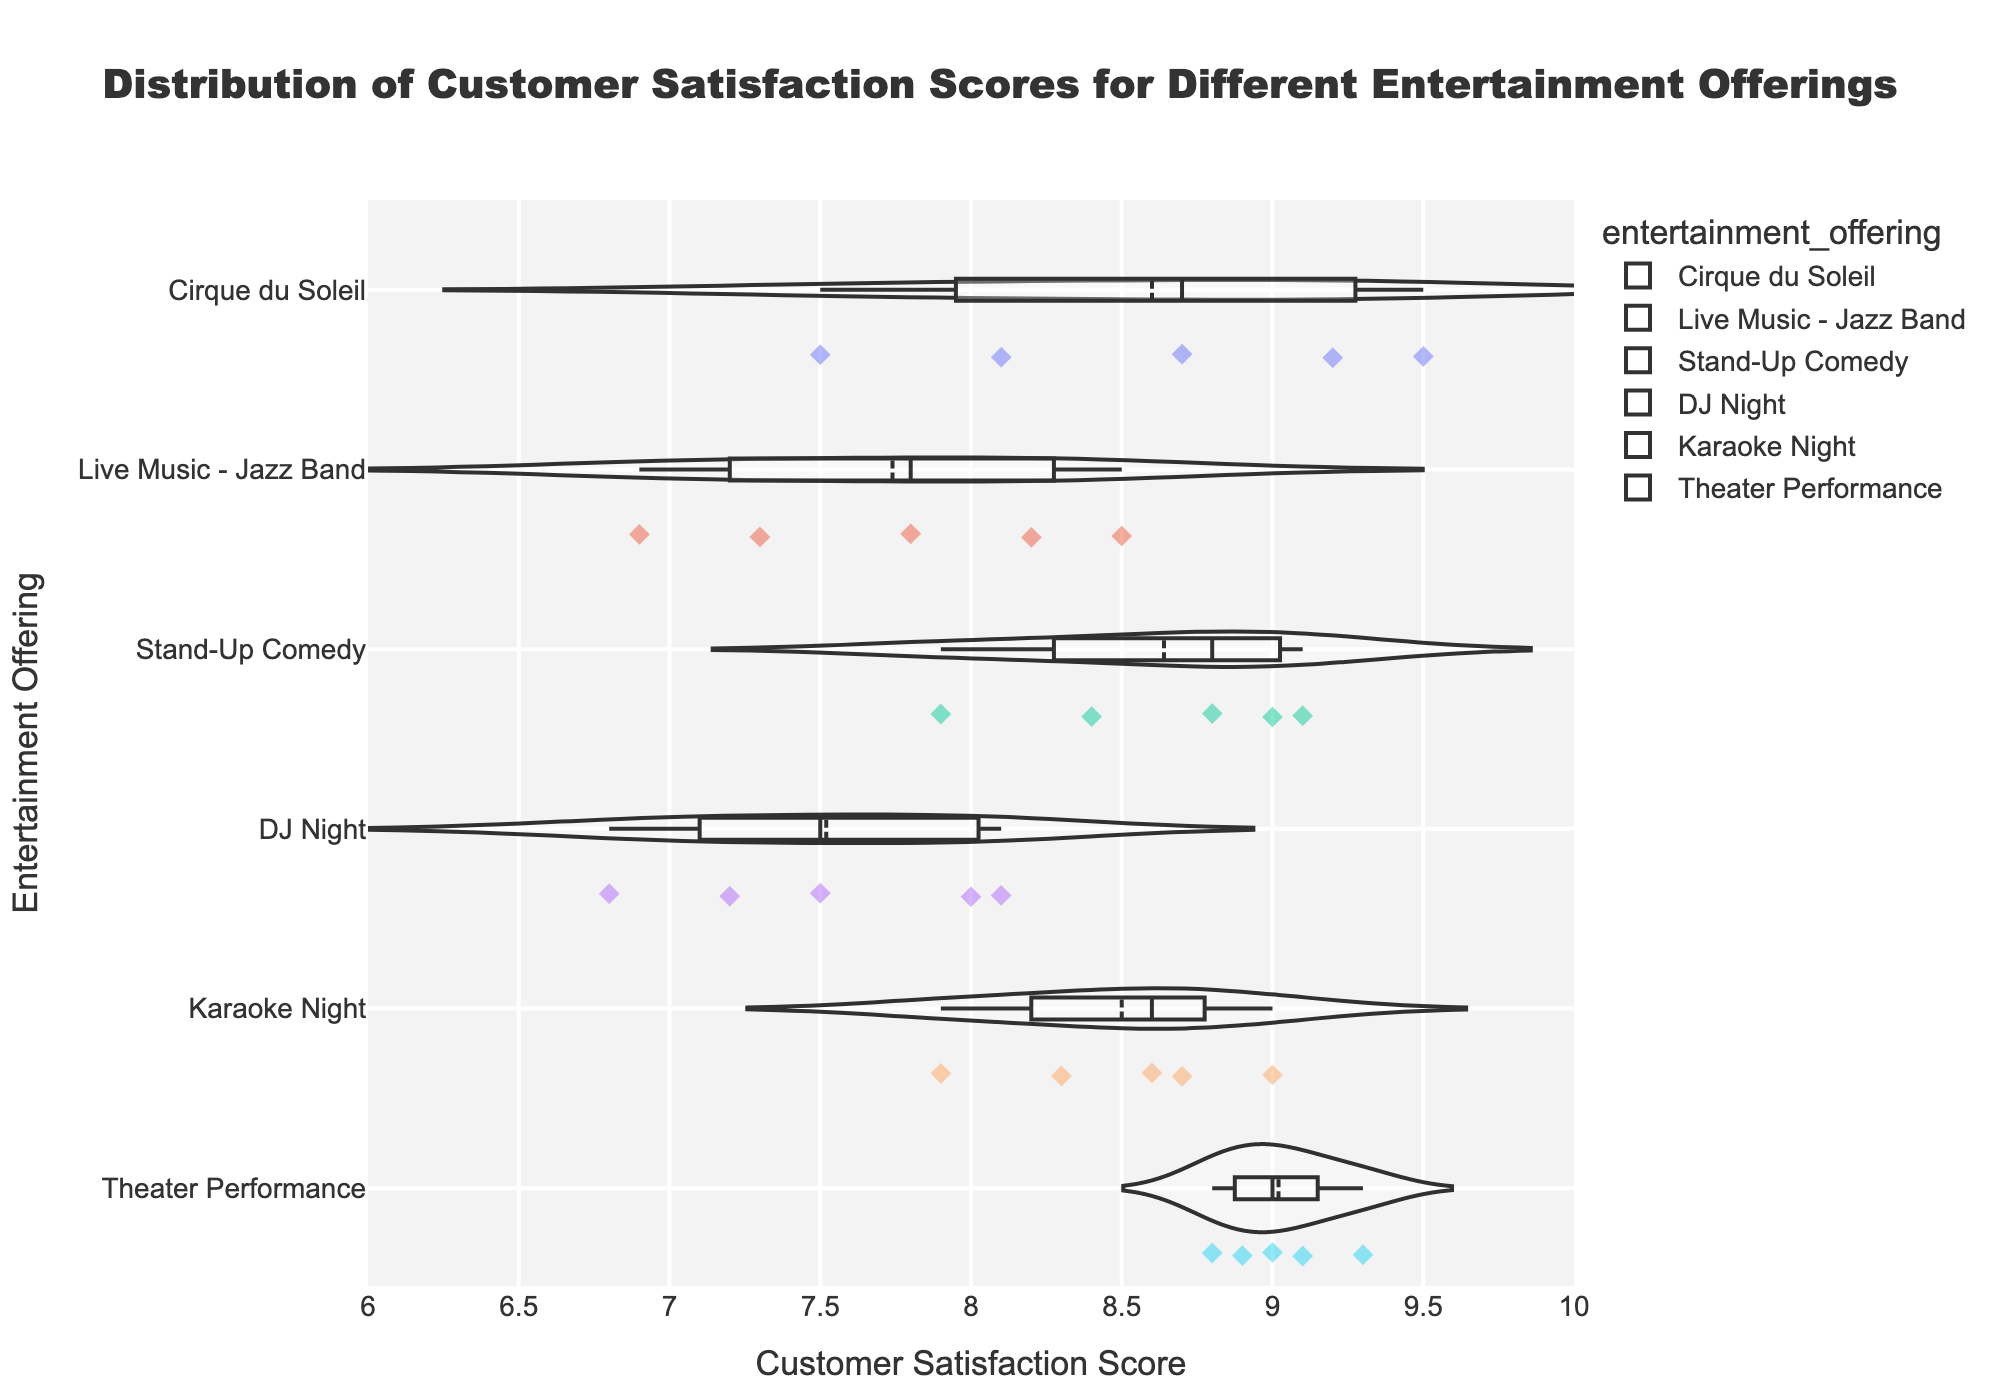How many entertainment offerings are displayed in the chart? Count the number of unique offerings listed on the y-axis. The y-axis shows Cirque du Soleil, Live Music - Jazz Band, Stand-Up Comedy, DJ Night, Karaoke Night, and Theater Performance.
Answer: 6 What is the average customer satisfaction score for Cirque du Soleil? Add the satisfaction scores for Cirque du Soleil (8.7, 9.2, 7.5, 8.1, 9.5), and divide by the number of scores, which is 5. (8.7 + 9.2 + 7.5 + 8.1 + 9.5) / 5 = 43 / 5 = 8.6
Answer: 8.6 Which entertainment offering has the highest median customer satisfaction score? Identify the median line within each violin plot. Cirque du Soleil has the highest median score around 8.7 while other offerings have lower median scores.
Answer: Theater Performance What is the range of customer satisfaction scores for Stand-Up Comedy? Look at the highest and lowest points in the violin plot for Stand-Up Comedy. The highest score is 9.1 and the lowest is 7.9. Subtract the lowest score from the highest score: 9.1 - 7.9 = 1.2
Answer: 1.2 Which entertainment offering has the lowest average customer satisfaction score? Calculate the average satisfaction score for each offering and then compare. Cirque du Soleil (8.6), Live Music - Jazz Band (7.74), Stand-Up Comedy (9.04), DJ Night (7.52), Karaoke Night (8.5), Theater Performance (8.82). DJ Night has the lowest average.
Answer: DJ Night Do any entertainment offerings have a satisfaction score above 9.0? If yes, which ones? Look at the points outside the box in the violin plots. Cirque du Soleil has 9.2 and 9.5, Stand-Up Comedy has 9.1, Karaoke Night has 9.0, Theater Performance has 9.3 and 9.1.
Answer: Cirque du Soleil, Stand-Up Comedy, Karaoke Night, Theater Performance Which entertainment offering has the widest spread of customer satisfaction scores? Compare the width of the spans in each violin plot. Cirque du Soleil spans from 7.5 to 9.5, which is wider compared to others.
Answer: Cirque du Soleil How does the customer satisfaction for Live Music - Jazz Band compare to DJ Night? Compare the medians and ranges of the satisfaction scores for both. Live Music - Jazz Band has a median around 8.0 and a range from 6.9 to 8.2, while DJ Night has a median around 7.5 and a range from 6.8 to 8.1. Live Music - Jazz Band has a higher median and a wider range.
Answer: Live Music - Jazz Band has a higher median and wider range What is the interquartile range (IQR) for Karaoke Night? Locate the points of the first quartile (Q1) and the third quartile (Q3) in the box of the violin plot. For Karaoke Night, Q1 is around 7.9 and Q3 is around 8.7. Subtract Q1 from Q3 to get the IQR: 8.7 - 7.9 = 0.8
Answer: 0.8 